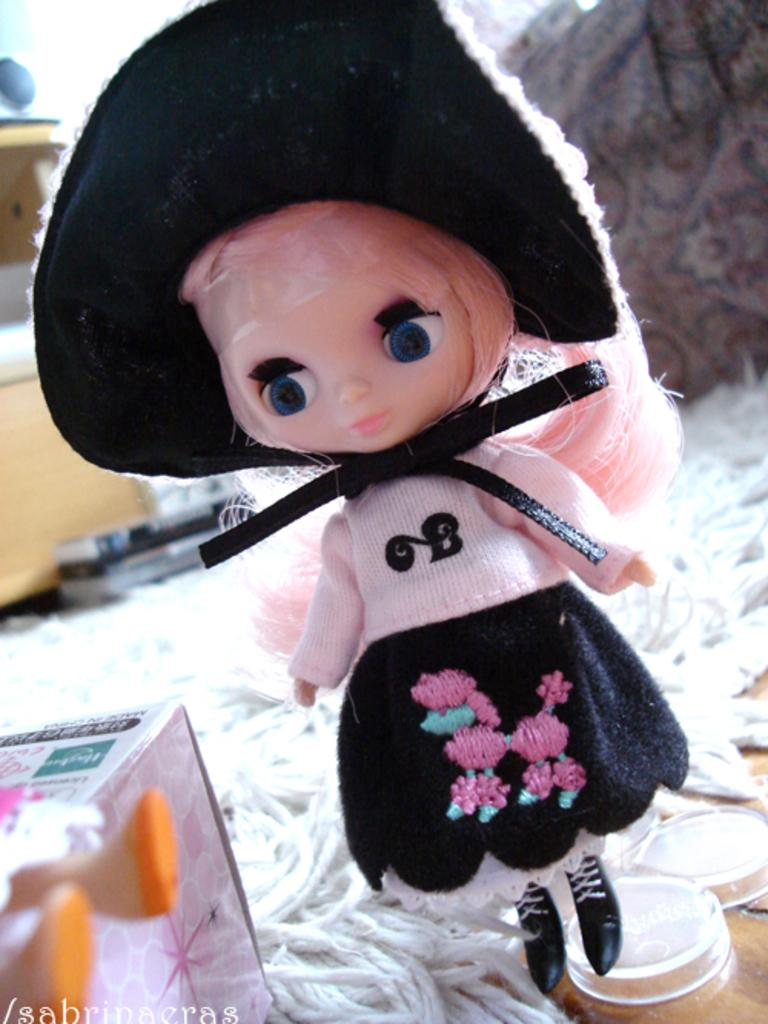What is the main object in the foreground of the image? There is a toy in the foreground of the image. What can be seen at the bottom of the image? There are threads and boxes at the bottom of the image. What is located in the background of the image? There is a table in the background of the image. What is on the table in the background of the image? There are objects on the table in the background of the image. What type of cable is visible in the image? There is no cable present in the image. How many things are on the table in the background of the image? The number of things on the table cannot be determined from the image alone, as it only states that there are objects on the table. 